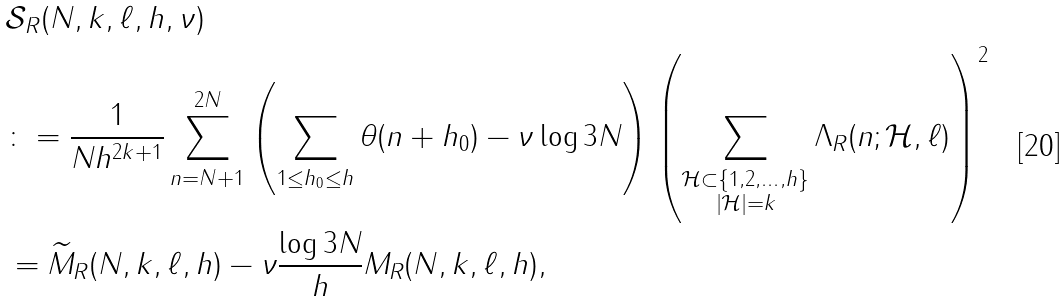Convert formula to latex. <formula><loc_0><loc_0><loc_500><loc_500>& \mathcal { S } _ { R } ( N , k , \ell , h , \nu ) \\ & \colon = \frac { 1 } { N h ^ { 2 k + 1 } } \sum _ { n = N + 1 } ^ { 2 N } \left ( \sum _ { 1 \leq h _ { 0 } \leq h } \theta ( n + h _ { 0 } ) - \nu \log 3 N \right ) \left ( \sum _ { \substack { \mathcal { H } \subset \{ 1 , 2 , \dots , h \} \\ | \mathcal { H } | = k } } \Lambda _ { R } ( n ; \mathcal { H } , \ell ) \right ) ^ { 2 } \\ & = \widetilde { M } _ { R } ( N , k , \ell , h ) - \nu \frac { \log 3 N } { h } M _ { R } ( N , k , \ell , h ) ,</formula> 